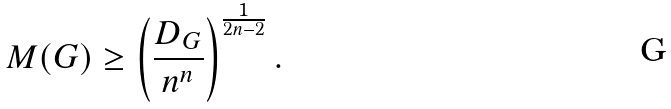Convert formula to latex. <formula><loc_0><loc_0><loc_500><loc_500>M ( G ) \geq \left ( \frac { D _ { G } } { n ^ { n } } \right ) ^ { \frac { 1 } { 2 n - 2 } } .</formula> 